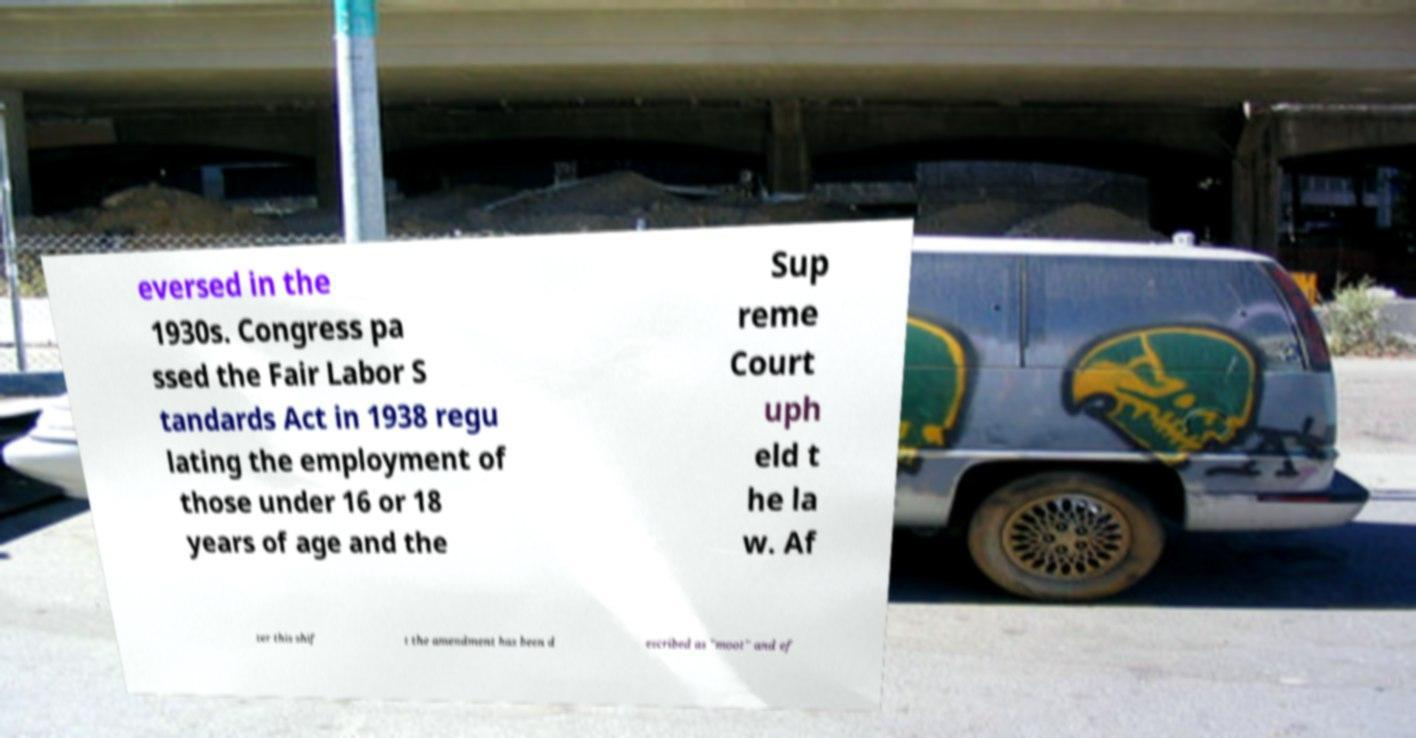Can you read and provide the text displayed in the image?This photo seems to have some interesting text. Can you extract and type it out for me? eversed in the 1930s. Congress pa ssed the Fair Labor S tandards Act in 1938 regu lating the employment of those under 16 or 18 years of age and the Sup reme Court uph eld t he la w. Af ter this shif t the amendment has been d escribed as "moot" and ef 